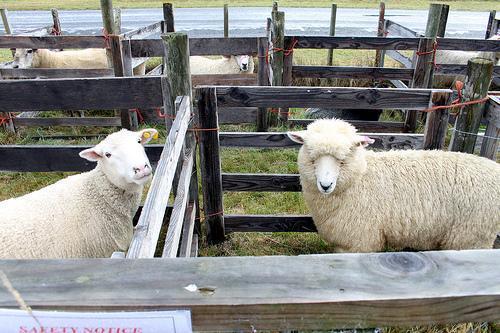How many lambs are there?
Give a very brief answer. 4. 